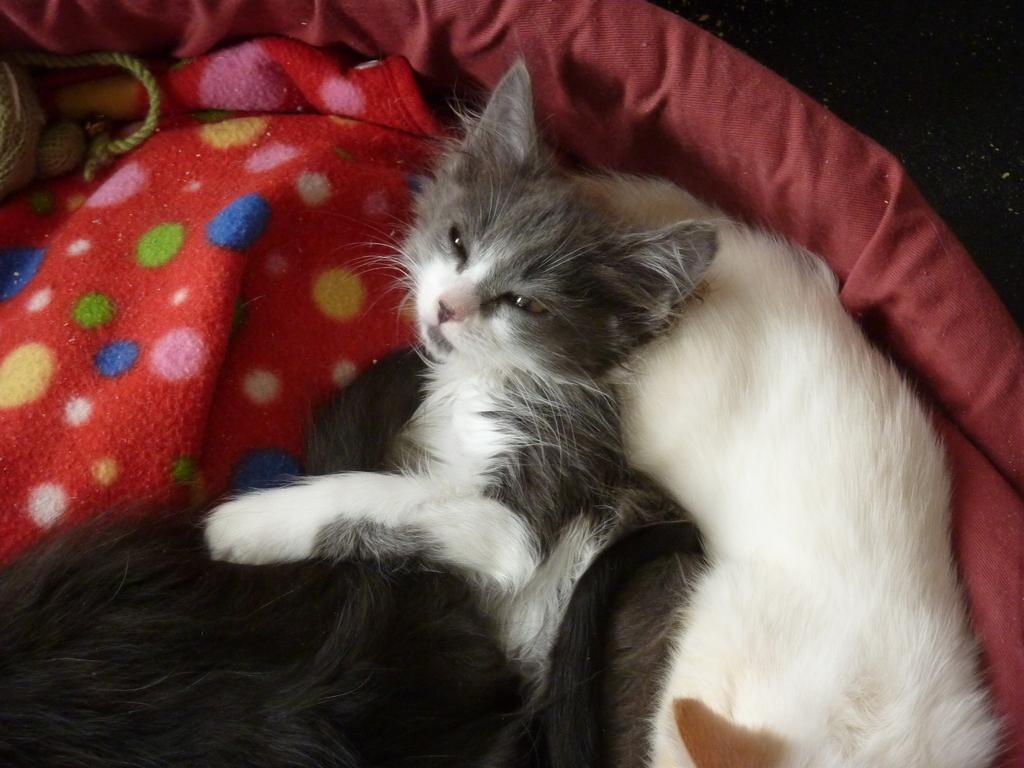What type of animal is in the picture? There is a cat in the picture. What is the cat doing in the picture? The cat is lying on the bed. Can you describe the appearance of the cat? The cat has gray and white fur. Are there any other animals in the picture? Yes, there is another cat in the picture. What is the second cat doing in the picture? The second cat is also lying on the bed. How does the second cat look like? The second cat has black fur. What else can be seen in the image? There is a rope on the left side of the image. What type of calculator is the cat using in the image? There is no calculator present in the image; it features two cats lying on the bed and a rope on the left side. 